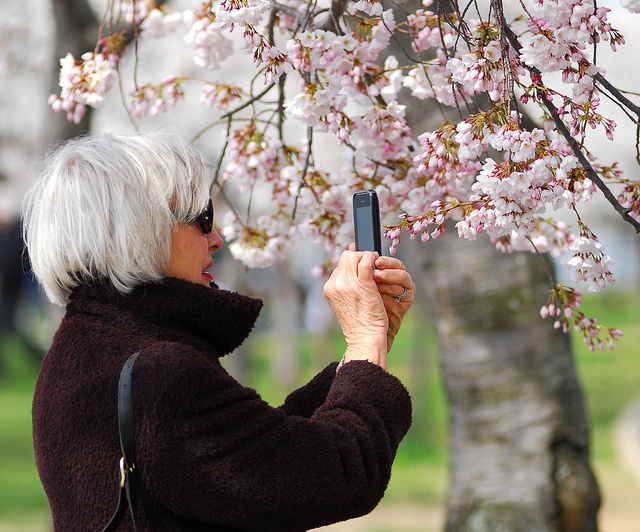Describe the objects in this image and their specific colors. I can see people in lightgray, black, darkgray, and gray tones, handbag in lightgray, black, and gray tones, and cell phone in lightgray, gray, black, and blue tones in this image. 